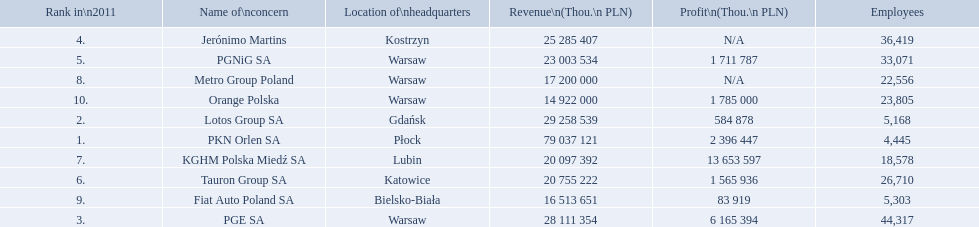What is the number of employees that work for pkn orlen sa in poland? 4,445. What number of employees work for lotos group sa? 5,168. How many people work for pgnig sa? 33,071. 